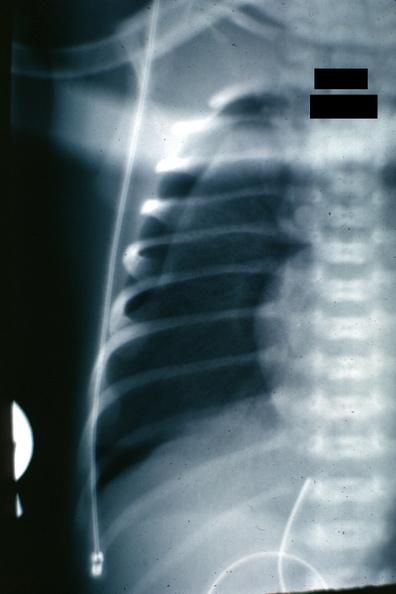where is this?
Answer the question using a single word or phrase. Lung 